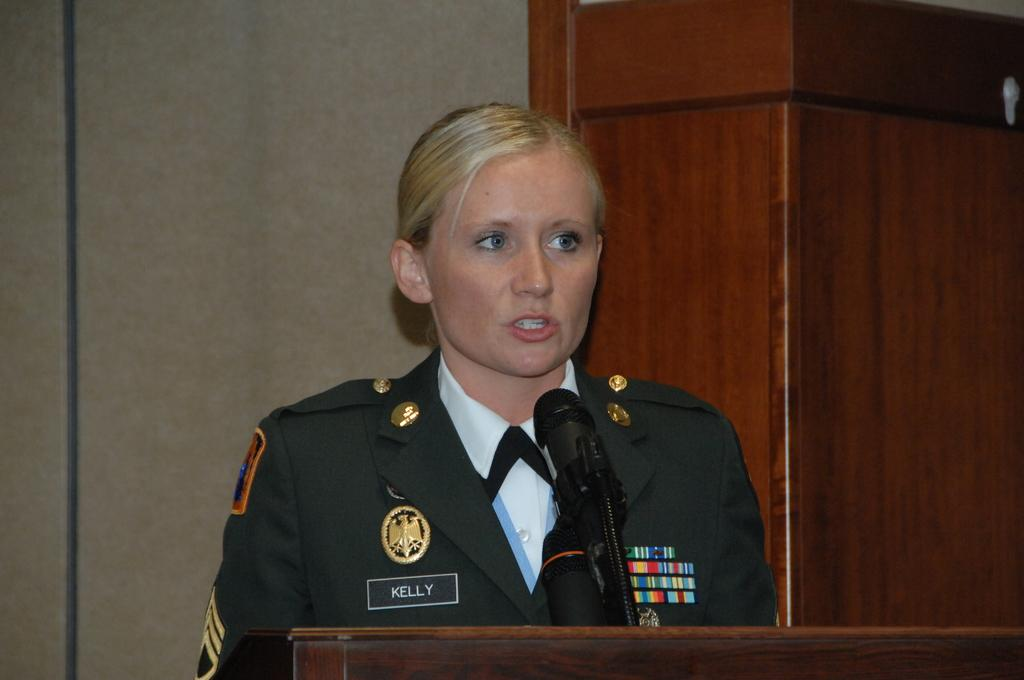Who is near the podium in the image? There is a person near the podium in the image. What can be seen on or around the podium? There are microphones (mikes) in the image. What is visible in the background of the image? There is a wall in the background of the image. Are there any ships visible in the image? No, there are no ships present in the image. What type of toys can be seen on the podium? There are no toys visible in the image; it features a person near a podium with microphones. 